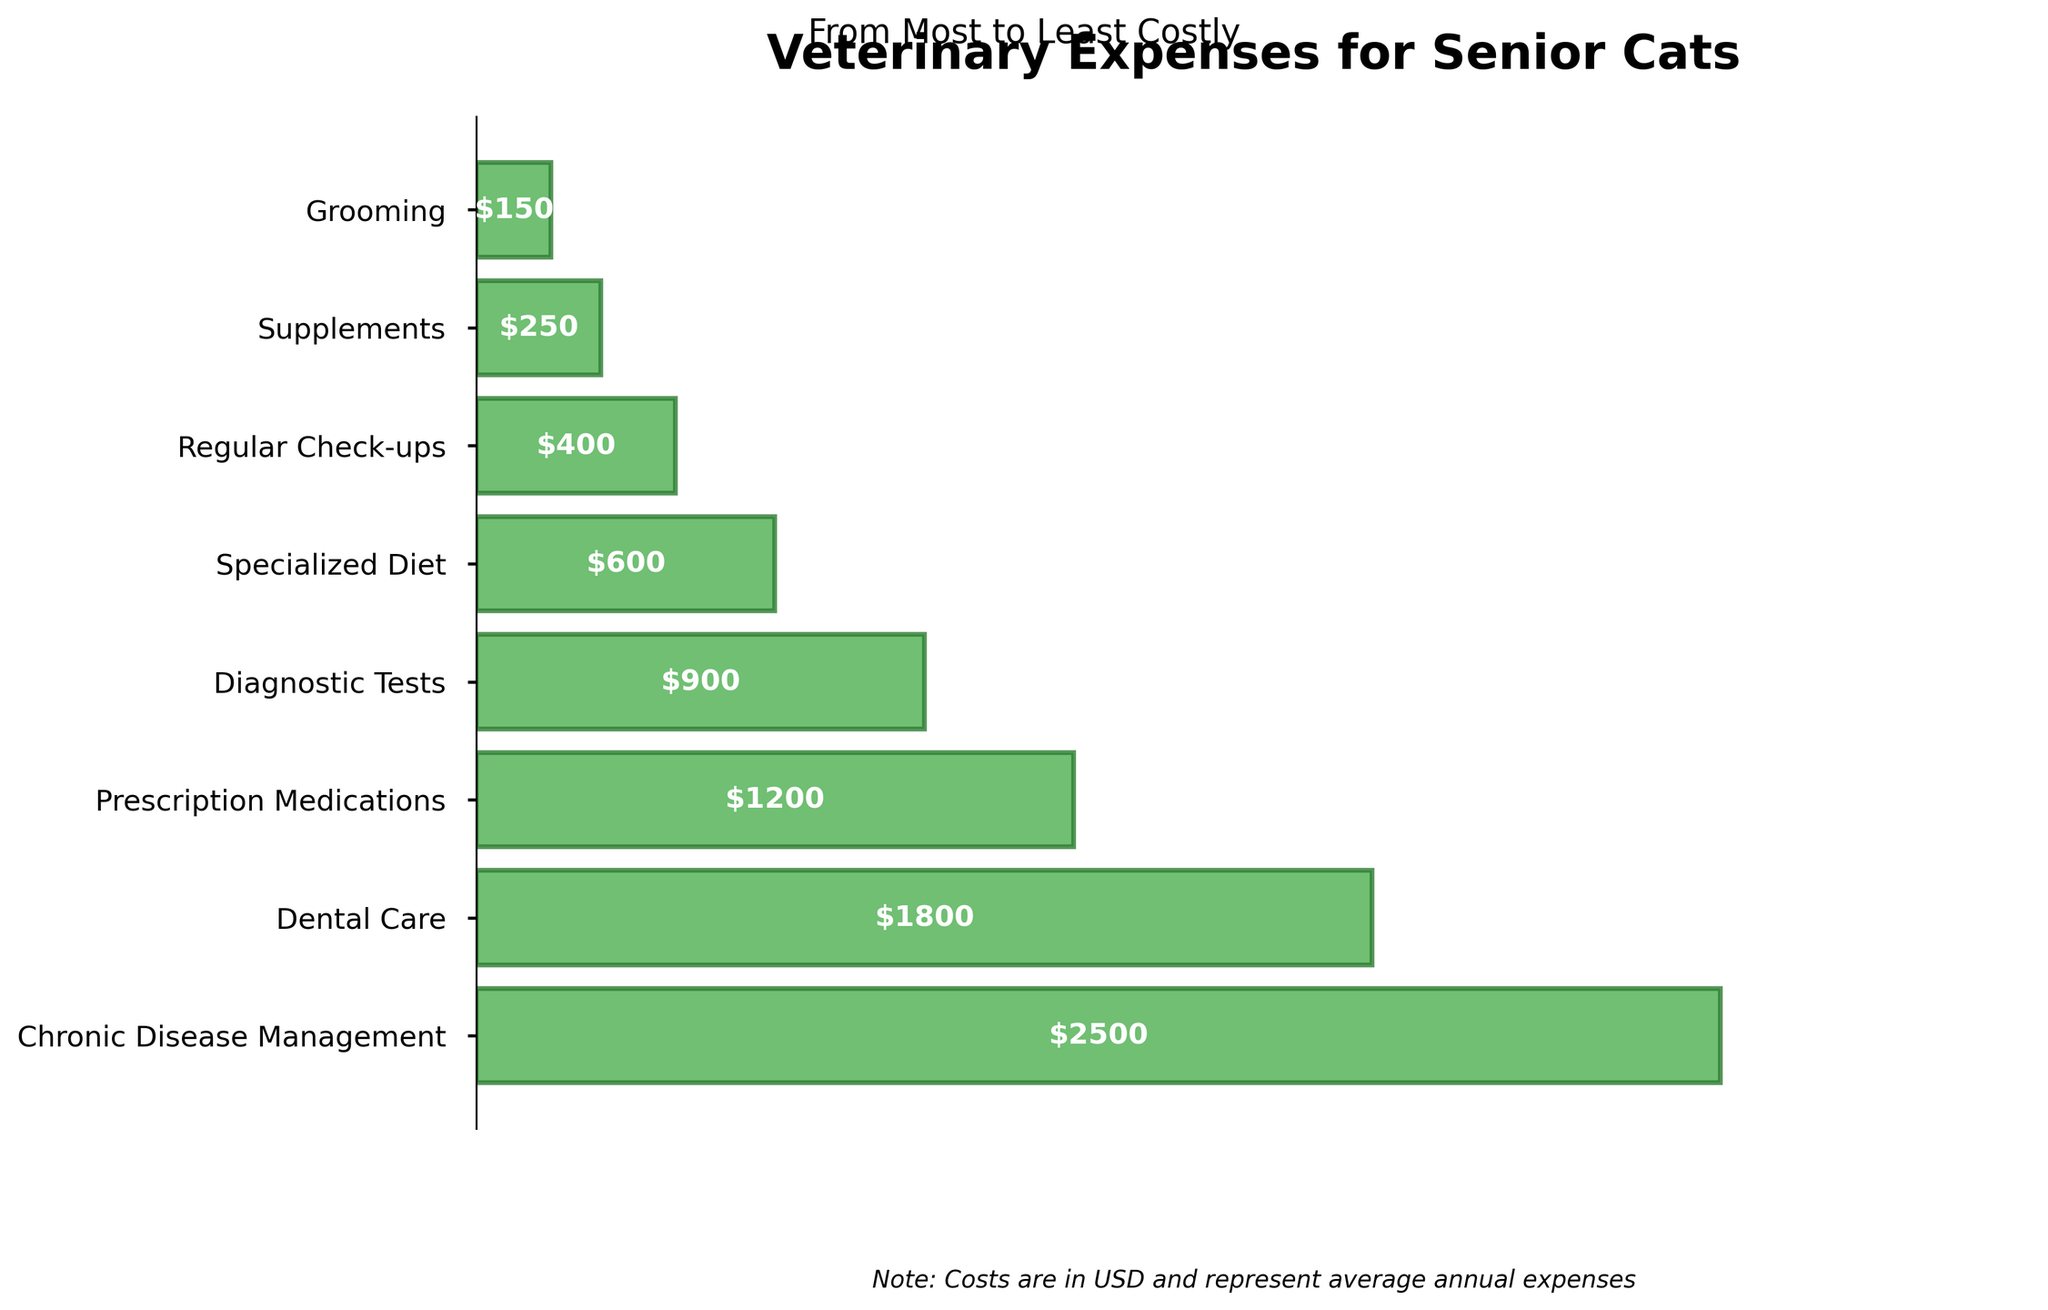what's the title of the chart? The title of the chart is located at the top of the figure. Based on the information provided, the title reads "Veterinary Expenses for Senior Cats".
Answer: Veterinary Expenses for Senior Cats how many categories of expenses are shown on the chart? There are horizontal bars representing different expense categories. Counting them from top to bottom will give the total number of categories.
Answer: 8 which expense category has the highest cost? The tallest bar represents the category with the highest cost. According to the data, this is "Chronic Disease Management".
Answer: Chronic Disease Management which expense category is the least costly? The shortest bar represents the category with the lowest cost. According to the data, this is "Grooming".
Answer: Grooming what is the cost of dental care for senior cats? The cost of dental care is labeled inside the corresponding bar. It is mentioned as $1800.
Answer: $1800 how much more is spent on prescription medications compared to supplements? To find the difference in costs, subtract the cost of supplements ($250) from the cost of prescription medications ($1200). The difference is $950.
Answer: $950 what is the combined cost of diagnostic tests and specialized diet? Add the cost of diagnostic tests ($900) and specialized diet ($600) together. The sum is $1500.
Answer: $1500 which expense is closest in cost to regular check-ups? The expense categories close to the cost of regular check-ups ($400) are "Supplements" ($250) and "Specialized Diet" ($600). "Specialized Diet" at $600 is closest.
Answer: Specialized Diet is the cost of grooming greater than that of supplements? Compare the costs labeled inside the bars for grooming ($150) and supplements ($250). Grooming costs less than supplements.
Answer: No how does the cost of chronic disease management compare to the cost of regular check-ups? The cost of chronic disease management ($2500) is significantly higher than the cost of regular check-ups ($400).
Answer: Significantly higher 